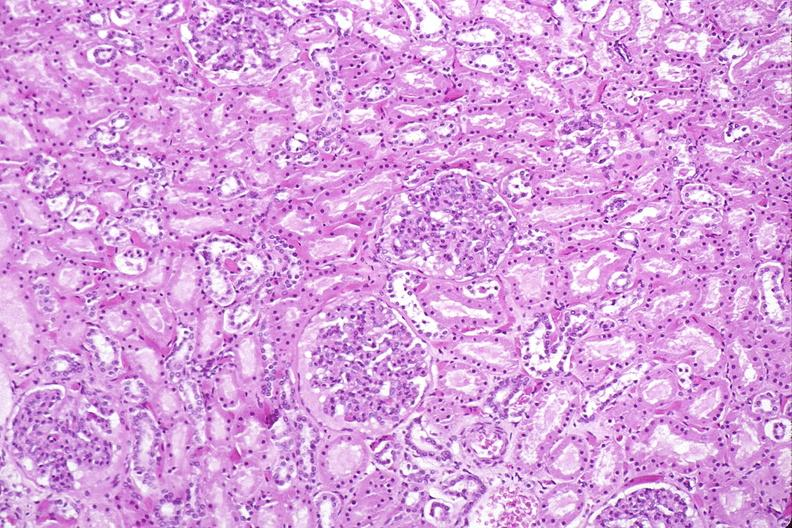does band constriction in skin above ankle of infant show kidney, normal histology?
Answer the question using a single word or phrase. No 